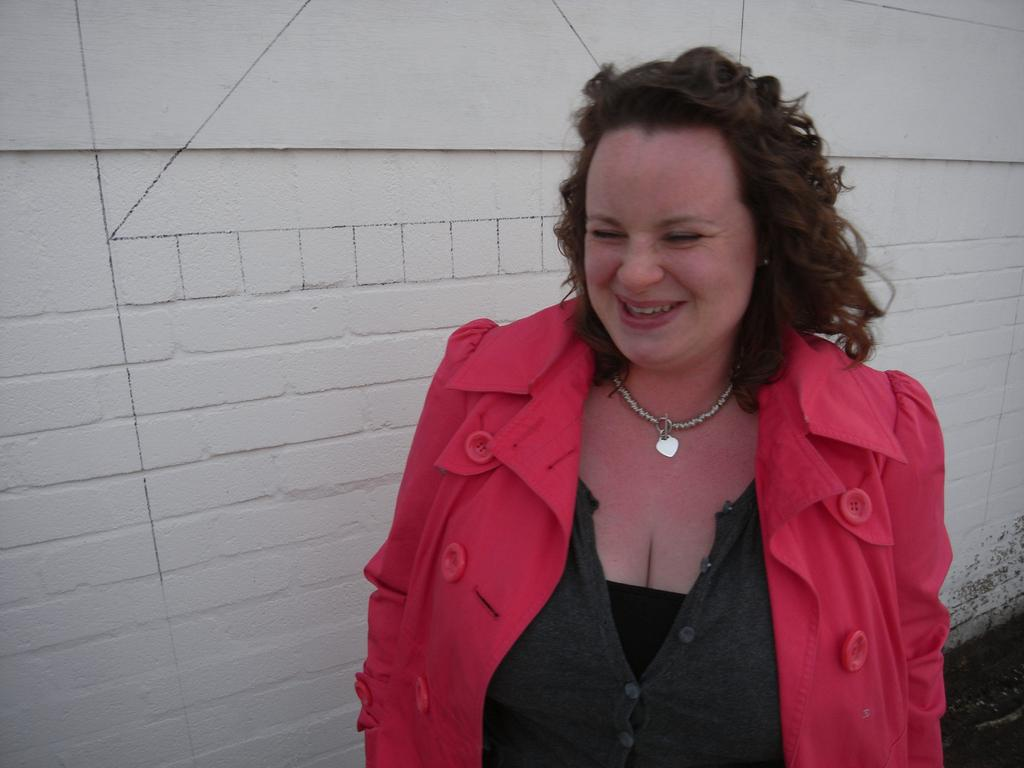What is the main subject of the image? There is a woman standing in the image. What is the woman's expression in the image? The woman is smiling in the image. What can be seen in the background of the image? There is a white color wall in the background of the image. What type of cow can be seen practicing a specific form of religion in the image? There is no cow or any religious practice present in the image; it features a woman standing in front of a white wall. 